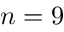Convert formula to latex. <formula><loc_0><loc_0><loc_500><loc_500>n = 9</formula> 